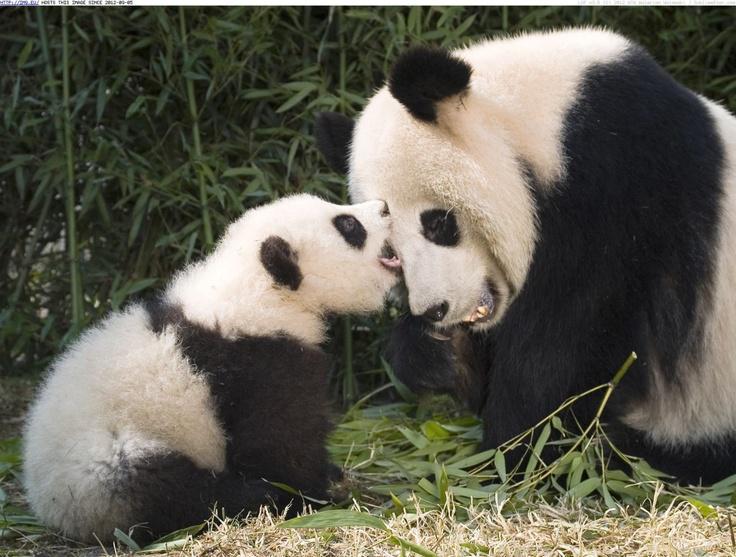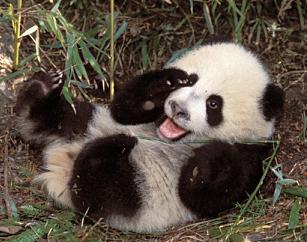The first image is the image on the left, the second image is the image on the right. Evaluate the accuracy of this statement regarding the images: "There are four pandas.". Is it true? Answer yes or no. No. The first image is the image on the left, the second image is the image on the right. Assess this claim about the two images: "There are four pandas.". Correct or not? Answer yes or no. No. 